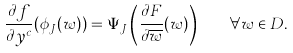<formula> <loc_0><loc_0><loc_500><loc_500>\frac { \partial f } { \partial y ^ { c } } ( \phi _ { J } ( w ) ) = \Psi _ { J } \left ( \frac { \partial F } { \partial \overline { w } } ( w ) \right ) \quad \forall w \in D .</formula> 